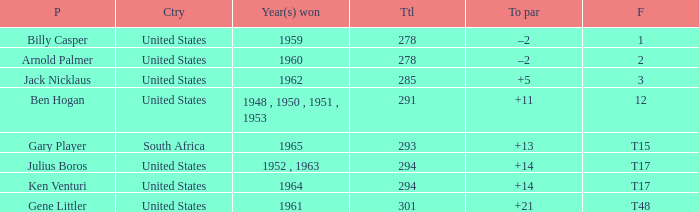Can you give me this table as a dict? {'header': ['P', 'Ctry', 'Year(s) won', 'Ttl', 'To par', 'F'], 'rows': [['Billy Casper', 'United States', '1959', '278', '–2', '1'], ['Arnold Palmer', 'United States', '1960', '278', '–2', '2'], ['Jack Nicklaus', 'United States', '1962', '285', '+5', '3'], ['Ben Hogan', 'United States', '1948 , 1950 , 1951 , 1953', '291', '+11', '12'], ['Gary Player', 'South Africa', '1965', '293', '+13', 'T15'], ['Julius Boros', 'United States', '1952 , 1963', '294', '+14', 'T17'], ['Ken Venturi', 'United States', '1964', '294', '+14', 'T17'], ['Gene Littler', 'United States', '1961', '301', '+21', 'T48']]} What is Finish, when Country is "United States", and when To Par is "+21"? T48. 